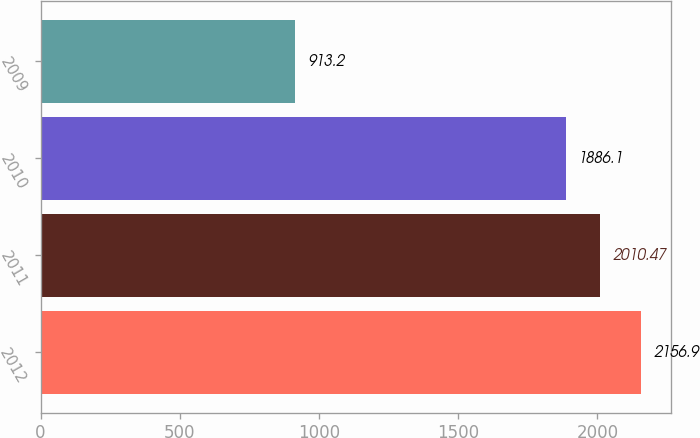Convert chart. <chart><loc_0><loc_0><loc_500><loc_500><bar_chart><fcel>2012<fcel>2011<fcel>2010<fcel>2009<nl><fcel>2156.9<fcel>2010.47<fcel>1886.1<fcel>913.2<nl></chart> 